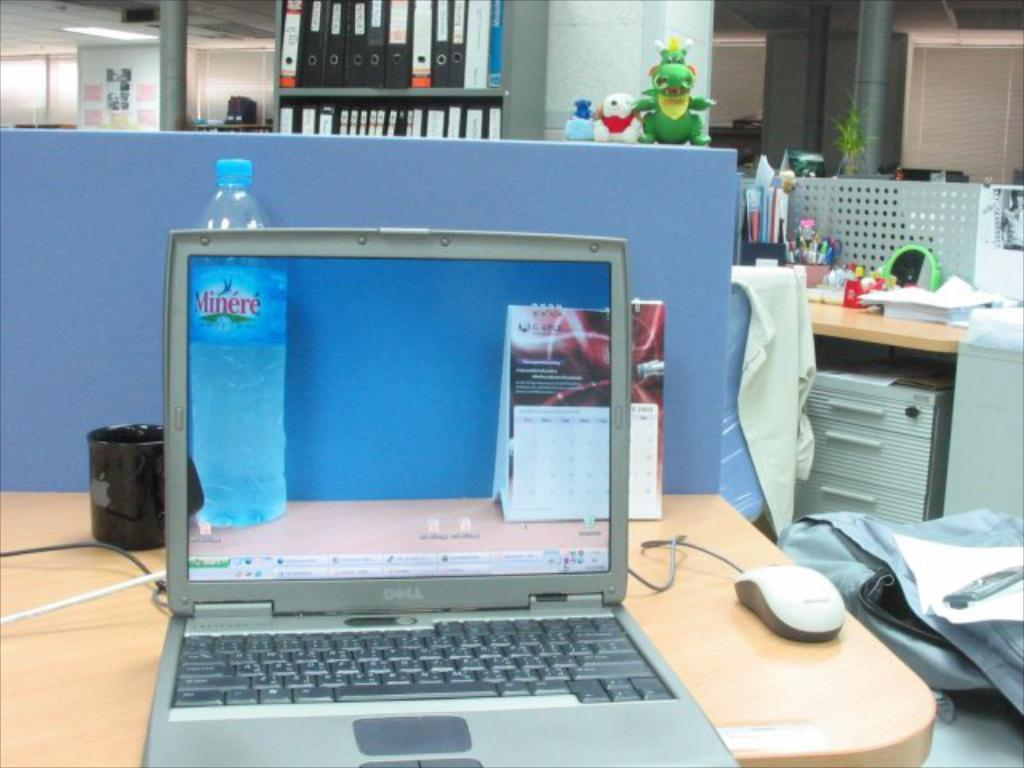<image>
Summarize the visual content of the image. an open dell laptop sitting on a cubicle desk 